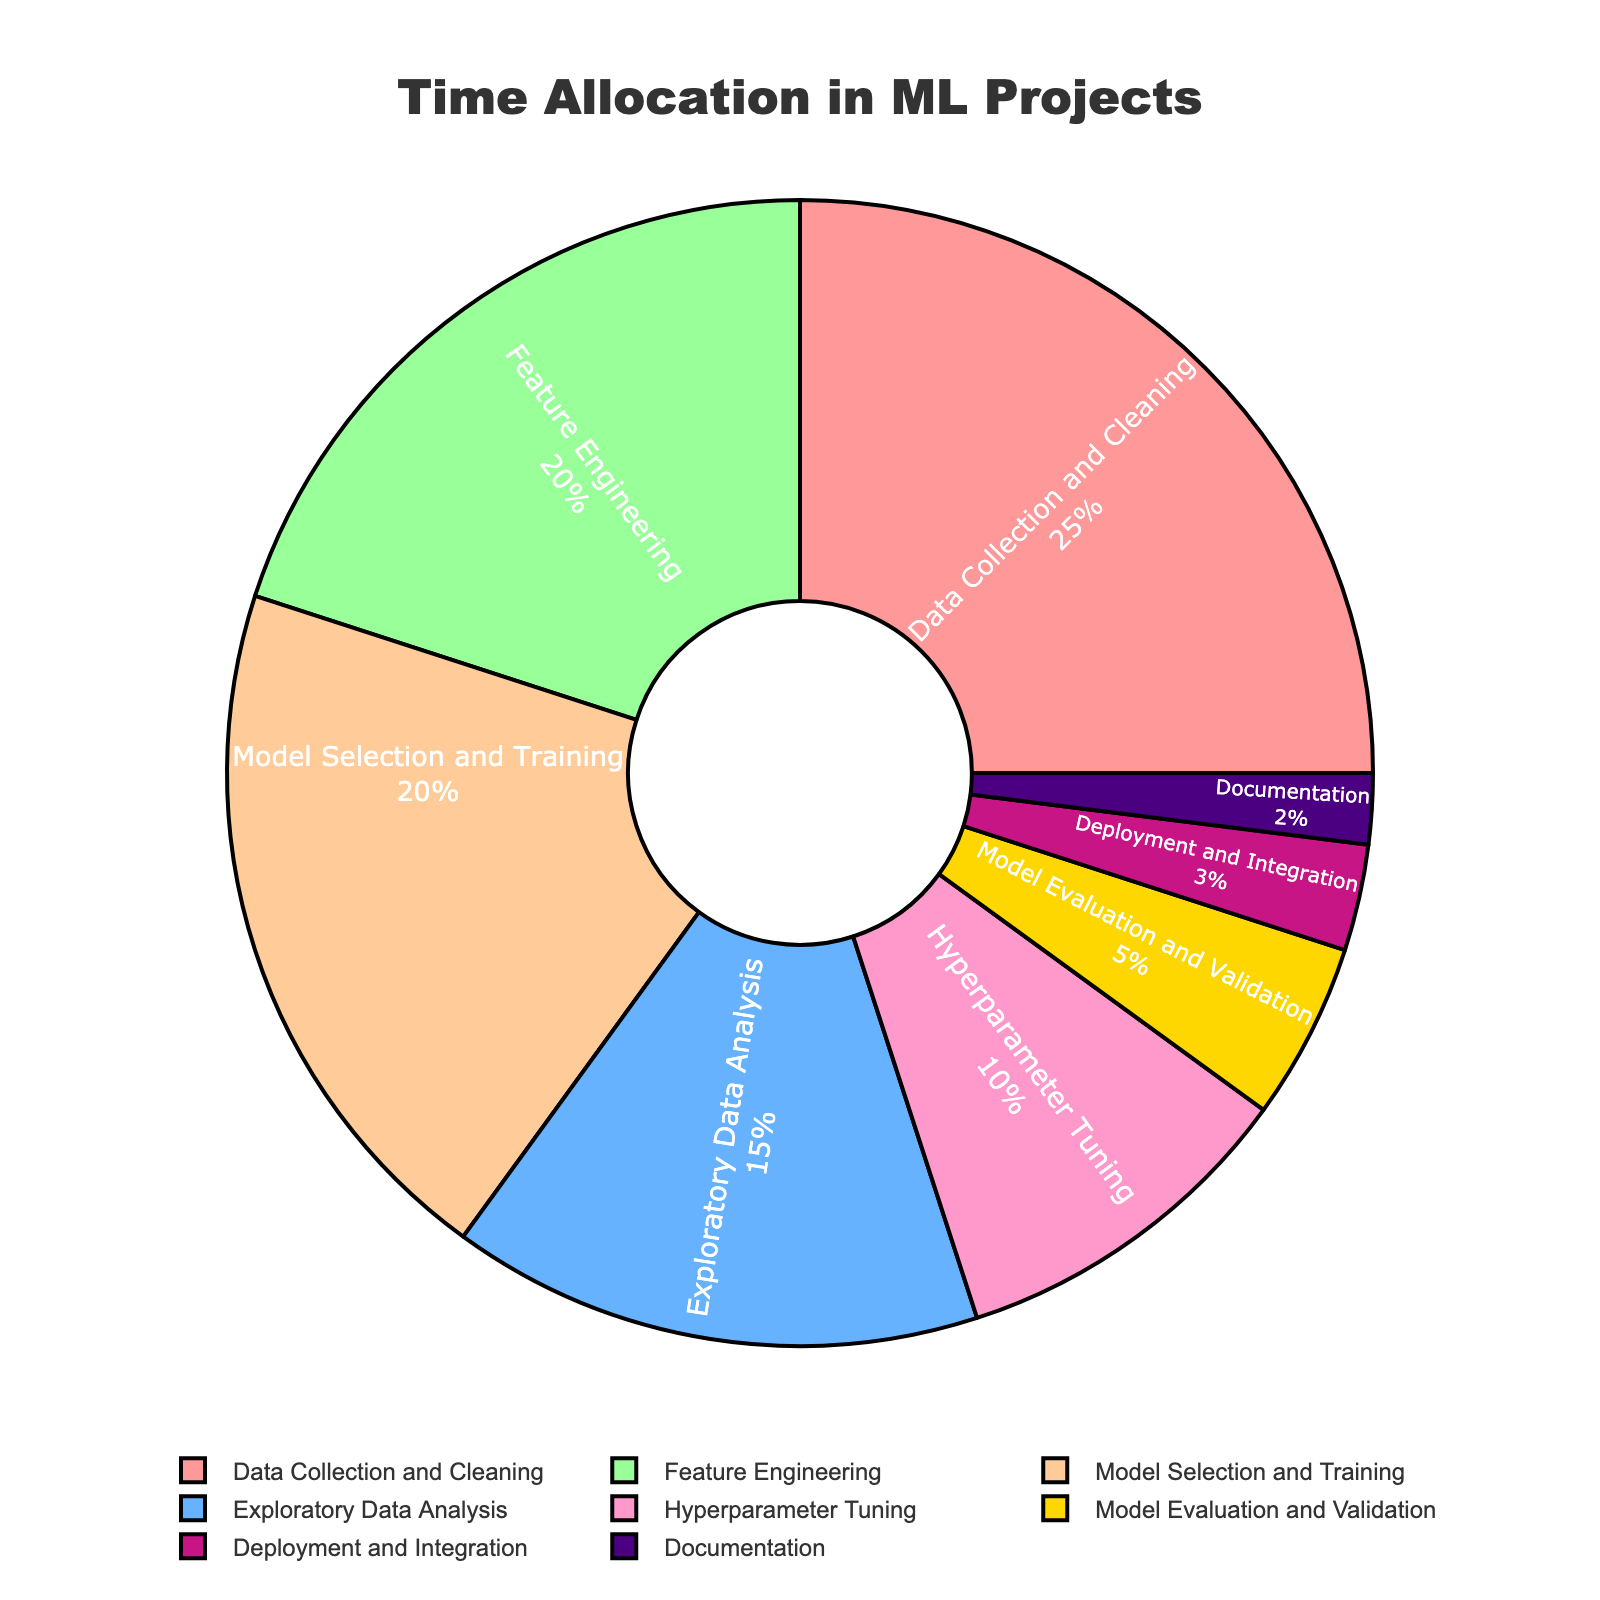How much time is allocated to Data Collection and Cleaning compared to Hyperparameter Tuning? Data Collection and Cleaning is 25%, Hyperparameter Tuning is 10%, so the difference is 25% - 10% = 15%
Answer: 15% What is the combined percentage of time spent on Feature Engineering, Model Selection and Training, and Hyperparameter Tuning? Feature Engineering is 20%, Model Selection and Training is 20%, and Hyperparameter Tuning is 10%. Their combined percentage is 20% + 20% + 10% = 50%
Answer: 50% Which phase has the smallest allocation of time, and how much is it? The smallest allocation is Documentation, with 2%
Answer: Documentation, 2% Are the percentages for Model Evaluation and Validation and Deployment and Integration equal? Model Evaluation and Validation is 5% and Deployment and Integration is 3%, so they are not equal
Answer: No What is the total percentage of time allocated to phases other than Data Collection and Cleaning? Data Collection and Cleaning is 25%, so the percentage for other phases is 100% - 25% = 75%
Answer: 75% Which phase has a larger time allocation: Exploratory Data Analysis or Model Evaluation and Validation? Exploratory Data Analysis is 15% and Model Evaluation and Validation is 5%. Therefore, Exploratory Data Analysis has a larger allocation
Answer: Exploratory Data Analysis What is the difference in time allocation between the phase with the highest allocation and the phase with the second highest allocation? The highest allocation is Data Collection and Cleaning at 25%, and the second highest allocations are Feature Engineering and Model Selection and Training at 20%. The difference is 25% - 20% = 5%
Answer: 5% How does the percentage of Deployment and Integration compare to Documentation? Deployment and Integration is 3% and Documentation is 2%. Deployment and Integration has a higher allocation
Answer: Deployment and Integration is higher What phases together make up exactly half of the total time allocation? Feature Engineering (20%) and Model Selection and Training (20%) together make 40%, adding Hyperparameter Tuning (10%) sums to exactly 50%
Answer: Feature Engineering, Model Selection and Training, Hyperparameter Tuning What percentage of time is allocated to phases related to actual model development (excluding Data Collection and Cleaning, Exploratory Data Analysis, and Documentation)? The phases are: Feature Engineering (20%), Model Selection and Training (20%), Hyperparameter Tuning (10%), Model Evaluation and Validation (5%), Deployment and Integration (3%). Adding these: 20% + 20% + 10% + 5% + 3% = 58%
Answer: 58% 